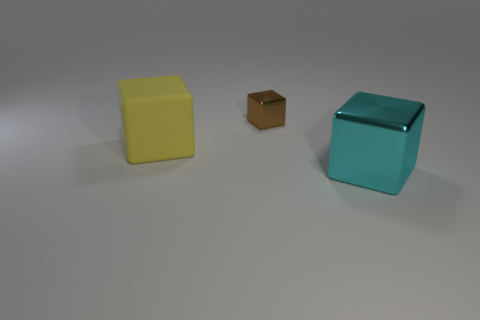Is the number of cyan cubes left of the cyan metallic cube the same as the number of tiny green metallic cylinders? Indeed, the number is the same. To the left of the cyan cube, we observe one smaller cube of brown shade, equal to the count of one tiny green metallic cylinder situated elsewhere in the scene. 